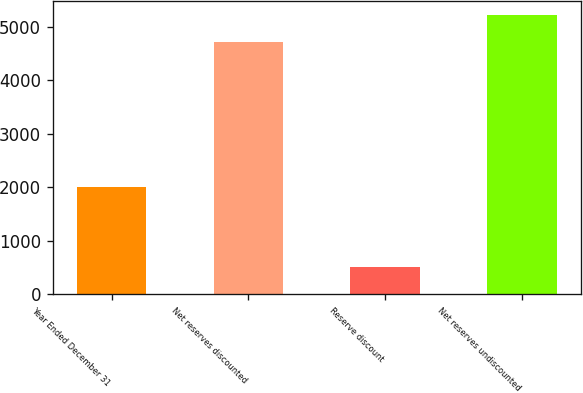Convert chart. <chart><loc_0><loc_0><loc_500><loc_500><bar_chart><fcel>Year Ended December 31<fcel>Net reserves discounted<fcel>Reserve discount<fcel>Net reserves undiscounted<nl><fcel>2004<fcel>4723<fcel>503<fcel>5226<nl></chart> 